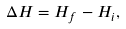<formula> <loc_0><loc_0><loc_500><loc_500>\Delta H = H _ { f } - H _ { i } ,</formula> 